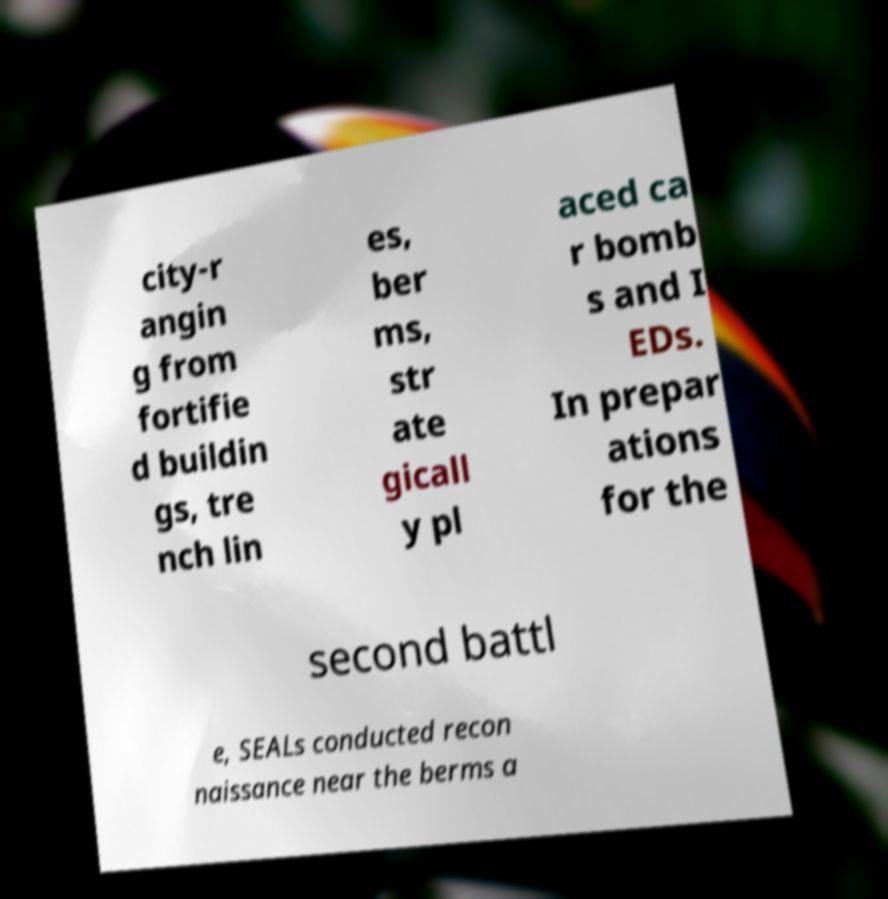For documentation purposes, I need the text within this image transcribed. Could you provide that? city-r angin g from fortifie d buildin gs, tre nch lin es, ber ms, str ate gicall y pl aced ca r bomb s and I EDs. In prepar ations for the second battl e, SEALs conducted recon naissance near the berms a 